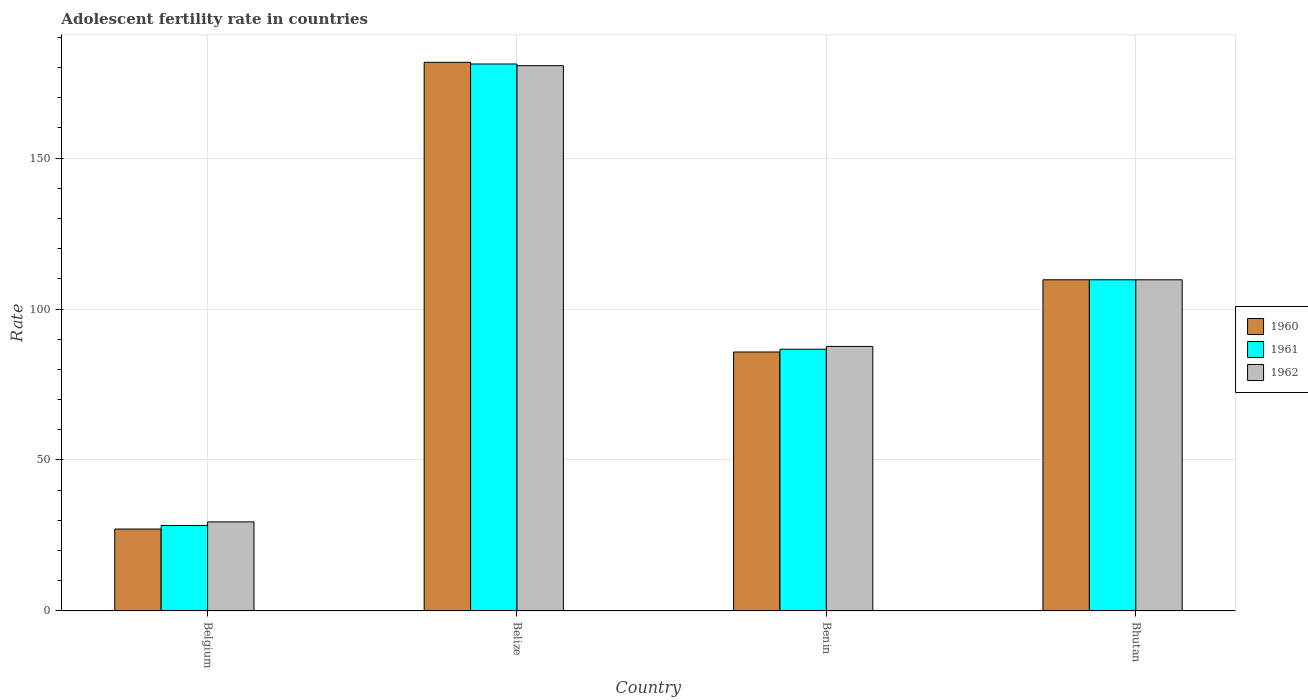Are the number of bars per tick equal to the number of legend labels?
Give a very brief answer. Yes. Are the number of bars on each tick of the X-axis equal?
Offer a very short reply. Yes. How many bars are there on the 1st tick from the right?
Make the answer very short. 3. What is the label of the 4th group of bars from the left?
Provide a short and direct response. Bhutan. In how many cases, is the number of bars for a given country not equal to the number of legend labels?
Give a very brief answer. 0. What is the adolescent fertility rate in 1962 in Benin?
Keep it short and to the point. 87.61. Across all countries, what is the maximum adolescent fertility rate in 1961?
Give a very brief answer. 181.16. Across all countries, what is the minimum adolescent fertility rate in 1961?
Your answer should be very brief. 28.3. In which country was the adolescent fertility rate in 1960 maximum?
Offer a terse response. Belize. What is the total adolescent fertility rate in 1960 in the graph?
Your answer should be compact. 404.28. What is the difference between the adolescent fertility rate in 1960 in Benin and that in Bhutan?
Ensure brevity in your answer.  -23.92. What is the difference between the adolescent fertility rate in 1960 in Belize and the adolescent fertility rate in 1961 in Belgium?
Your answer should be compact. 153.42. What is the average adolescent fertility rate in 1961 per country?
Offer a terse response. 101.46. What is the difference between the adolescent fertility rate of/in 1960 and adolescent fertility rate of/in 1962 in Benin?
Ensure brevity in your answer.  -1.85. In how many countries, is the adolescent fertility rate in 1960 greater than 150?
Make the answer very short. 1. What is the ratio of the adolescent fertility rate in 1961 in Belize to that in Benin?
Provide a succinct answer. 2.09. Is the adolescent fertility rate in 1960 in Belgium less than that in Bhutan?
Your answer should be compact. Yes. What is the difference between the highest and the second highest adolescent fertility rate in 1962?
Ensure brevity in your answer.  70.92. What is the difference between the highest and the lowest adolescent fertility rate in 1961?
Offer a terse response. 152.86. Is the sum of the adolescent fertility rate in 1960 in Belgium and Belize greater than the maximum adolescent fertility rate in 1961 across all countries?
Give a very brief answer. Yes. What does the 2nd bar from the right in Belize represents?
Provide a succinct answer. 1961. Are all the bars in the graph horizontal?
Offer a terse response. No. How many countries are there in the graph?
Your answer should be very brief. 4. What is the difference between two consecutive major ticks on the Y-axis?
Give a very brief answer. 50. Does the graph contain any zero values?
Make the answer very short. No. Does the graph contain grids?
Offer a very short reply. Yes. Where does the legend appear in the graph?
Give a very brief answer. Center right. How many legend labels are there?
Your answer should be very brief. 3. How are the legend labels stacked?
Offer a terse response. Vertical. What is the title of the graph?
Offer a very short reply. Adolescent fertility rate in countries. Does "1962" appear as one of the legend labels in the graph?
Your response must be concise. Yes. What is the label or title of the Y-axis?
Ensure brevity in your answer.  Rate. What is the Rate of 1960 in Belgium?
Offer a terse response. 27.11. What is the Rate in 1961 in Belgium?
Give a very brief answer. 28.3. What is the Rate of 1962 in Belgium?
Make the answer very short. 29.48. What is the Rate in 1960 in Belize?
Your answer should be compact. 181.72. What is the Rate in 1961 in Belize?
Your response must be concise. 181.16. What is the Rate of 1962 in Belize?
Your answer should be very brief. 180.6. What is the Rate in 1960 in Benin?
Give a very brief answer. 85.76. What is the Rate in 1961 in Benin?
Keep it short and to the point. 86.69. What is the Rate in 1962 in Benin?
Your answer should be compact. 87.61. What is the Rate in 1960 in Bhutan?
Your answer should be very brief. 109.68. What is the Rate of 1961 in Bhutan?
Keep it short and to the point. 109.68. What is the Rate in 1962 in Bhutan?
Your response must be concise. 109.68. Across all countries, what is the maximum Rate of 1960?
Your response must be concise. 181.72. Across all countries, what is the maximum Rate in 1961?
Make the answer very short. 181.16. Across all countries, what is the maximum Rate in 1962?
Ensure brevity in your answer.  180.6. Across all countries, what is the minimum Rate in 1960?
Provide a short and direct response. 27.11. Across all countries, what is the minimum Rate of 1961?
Your answer should be compact. 28.3. Across all countries, what is the minimum Rate of 1962?
Offer a very short reply. 29.48. What is the total Rate in 1960 in the graph?
Keep it short and to the point. 404.28. What is the total Rate of 1961 in the graph?
Your response must be concise. 405.83. What is the total Rate in 1962 in the graph?
Make the answer very short. 407.37. What is the difference between the Rate in 1960 in Belgium and that in Belize?
Give a very brief answer. -154.61. What is the difference between the Rate in 1961 in Belgium and that in Belize?
Offer a very short reply. -152.86. What is the difference between the Rate of 1962 in Belgium and that in Belize?
Your answer should be very brief. -151.12. What is the difference between the Rate in 1960 in Belgium and that in Benin?
Give a very brief answer. -58.65. What is the difference between the Rate of 1961 in Belgium and that in Benin?
Provide a short and direct response. -58.39. What is the difference between the Rate in 1962 in Belgium and that in Benin?
Give a very brief answer. -58.12. What is the difference between the Rate in 1960 in Belgium and that in Bhutan?
Offer a very short reply. -82.57. What is the difference between the Rate of 1961 in Belgium and that in Bhutan?
Provide a short and direct response. -81.38. What is the difference between the Rate of 1962 in Belgium and that in Bhutan?
Your answer should be very brief. -80.2. What is the difference between the Rate in 1960 in Belize and that in Benin?
Offer a very short reply. 95.96. What is the difference between the Rate in 1961 in Belize and that in Benin?
Keep it short and to the point. 94.47. What is the difference between the Rate of 1962 in Belize and that in Benin?
Your answer should be compact. 92.99. What is the difference between the Rate of 1960 in Belize and that in Bhutan?
Your answer should be very brief. 72.04. What is the difference between the Rate in 1961 in Belize and that in Bhutan?
Give a very brief answer. 71.48. What is the difference between the Rate in 1962 in Belize and that in Bhutan?
Provide a succinct answer. 70.92. What is the difference between the Rate of 1960 in Benin and that in Bhutan?
Ensure brevity in your answer.  -23.92. What is the difference between the Rate in 1961 in Benin and that in Bhutan?
Offer a very short reply. -23. What is the difference between the Rate in 1962 in Benin and that in Bhutan?
Provide a succinct answer. -22.07. What is the difference between the Rate of 1960 in Belgium and the Rate of 1961 in Belize?
Your response must be concise. -154.05. What is the difference between the Rate of 1960 in Belgium and the Rate of 1962 in Belize?
Ensure brevity in your answer.  -153.49. What is the difference between the Rate in 1961 in Belgium and the Rate in 1962 in Belize?
Provide a succinct answer. -152.3. What is the difference between the Rate of 1960 in Belgium and the Rate of 1961 in Benin?
Offer a very short reply. -59.57. What is the difference between the Rate in 1960 in Belgium and the Rate in 1962 in Benin?
Ensure brevity in your answer.  -60.49. What is the difference between the Rate of 1961 in Belgium and the Rate of 1962 in Benin?
Your answer should be very brief. -59.31. What is the difference between the Rate of 1960 in Belgium and the Rate of 1961 in Bhutan?
Keep it short and to the point. -82.57. What is the difference between the Rate of 1960 in Belgium and the Rate of 1962 in Bhutan?
Make the answer very short. -82.57. What is the difference between the Rate of 1961 in Belgium and the Rate of 1962 in Bhutan?
Your answer should be very brief. -81.38. What is the difference between the Rate in 1960 in Belize and the Rate in 1961 in Benin?
Provide a short and direct response. 95.03. What is the difference between the Rate of 1960 in Belize and the Rate of 1962 in Benin?
Provide a short and direct response. 94.11. What is the difference between the Rate in 1961 in Belize and the Rate in 1962 in Benin?
Make the answer very short. 93.55. What is the difference between the Rate of 1960 in Belize and the Rate of 1961 in Bhutan?
Ensure brevity in your answer.  72.04. What is the difference between the Rate of 1960 in Belize and the Rate of 1962 in Bhutan?
Keep it short and to the point. 72.04. What is the difference between the Rate in 1961 in Belize and the Rate in 1962 in Bhutan?
Your answer should be very brief. 71.48. What is the difference between the Rate of 1960 in Benin and the Rate of 1961 in Bhutan?
Offer a terse response. -23.92. What is the difference between the Rate of 1960 in Benin and the Rate of 1962 in Bhutan?
Your response must be concise. -23.92. What is the difference between the Rate of 1961 in Benin and the Rate of 1962 in Bhutan?
Make the answer very short. -23. What is the average Rate in 1960 per country?
Ensure brevity in your answer.  101.07. What is the average Rate in 1961 per country?
Make the answer very short. 101.46. What is the average Rate in 1962 per country?
Give a very brief answer. 101.84. What is the difference between the Rate of 1960 and Rate of 1961 in Belgium?
Your answer should be compact. -1.18. What is the difference between the Rate of 1960 and Rate of 1962 in Belgium?
Your answer should be compact. -2.37. What is the difference between the Rate of 1961 and Rate of 1962 in Belgium?
Your response must be concise. -1.18. What is the difference between the Rate of 1960 and Rate of 1961 in Belize?
Give a very brief answer. 0.56. What is the difference between the Rate in 1960 and Rate in 1962 in Belize?
Your answer should be very brief. 1.12. What is the difference between the Rate of 1961 and Rate of 1962 in Belize?
Your response must be concise. 0.56. What is the difference between the Rate of 1960 and Rate of 1961 in Benin?
Keep it short and to the point. -0.92. What is the difference between the Rate in 1960 and Rate in 1962 in Benin?
Keep it short and to the point. -1.85. What is the difference between the Rate of 1961 and Rate of 1962 in Benin?
Offer a terse response. -0.92. What is the difference between the Rate in 1960 and Rate in 1961 in Bhutan?
Offer a terse response. 0. What is the difference between the Rate in 1960 and Rate in 1962 in Bhutan?
Your answer should be very brief. 0. What is the ratio of the Rate of 1960 in Belgium to that in Belize?
Provide a succinct answer. 0.15. What is the ratio of the Rate of 1961 in Belgium to that in Belize?
Keep it short and to the point. 0.16. What is the ratio of the Rate in 1962 in Belgium to that in Belize?
Make the answer very short. 0.16. What is the ratio of the Rate in 1960 in Belgium to that in Benin?
Your answer should be compact. 0.32. What is the ratio of the Rate in 1961 in Belgium to that in Benin?
Your answer should be compact. 0.33. What is the ratio of the Rate in 1962 in Belgium to that in Benin?
Make the answer very short. 0.34. What is the ratio of the Rate of 1960 in Belgium to that in Bhutan?
Give a very brief answer. 0.25. What is the ratio of the Rate of 1961 in Belgium to that in Bhutan?
Give a very brief answer. 0.26. What is the ratio of the Rate of 1962 in Belgium to that in Bhutan?
Give a very brief answer. 0.27. What is the ratio of the Rate of 1960 in Belize to that in Benin?
Keep it short and to the point. 2.12. What is the ratio of the Rate in 1961 in Belize to that in Benin?
Your response must be concise. 2.09. What is the ratio of the Rate in 1962 in Belize to that in Benin?
Make the answer very short. 2.06. What is the ratio of the Rate of 1960 in Belize to that in Bhutan?
Provide a succinct answer. 1.66. What is the ratio of the Rate in 1961 in Belize to that in Bhutan?
Give a very brief answer. 1.65. What is the ratio of the Rate of 1962 in Belize to that in Bhutan?
Your answer should be compact. 1.65. What is the ratio of the Rate in 1960 in Benin to that in Bhutan?
Offer a terse response. 0.78. What is the ratio of the Rate of 1961 in Benin to that in Bhutan?
Your answer should be very brief. 0.79. What is the ratio of the Rate of 1962 in Benin to that in Bhutan?
Your answer should be very brief. 0.8. What is the difference between the highest and the second highest Rate in 1960?
Offer a very short reply. 72.04. What is the difference between the highest and the second highest Rate of 1961?
Offer a very short reply. 71.48. What is the difference between the highest and the second highest Rate of 1962?
Make the answer very short. 70.92. What is the difference between the highest and the lowest Rate of 1960?
Offer a very short reply. 154.61. What is the difference between the highest and the lowest Rate of 1961?
Give a very brief answer. 152.86. What is the difference between the highest and the lowest Rate of 1962?
Your answer should be compact. 151.12. 